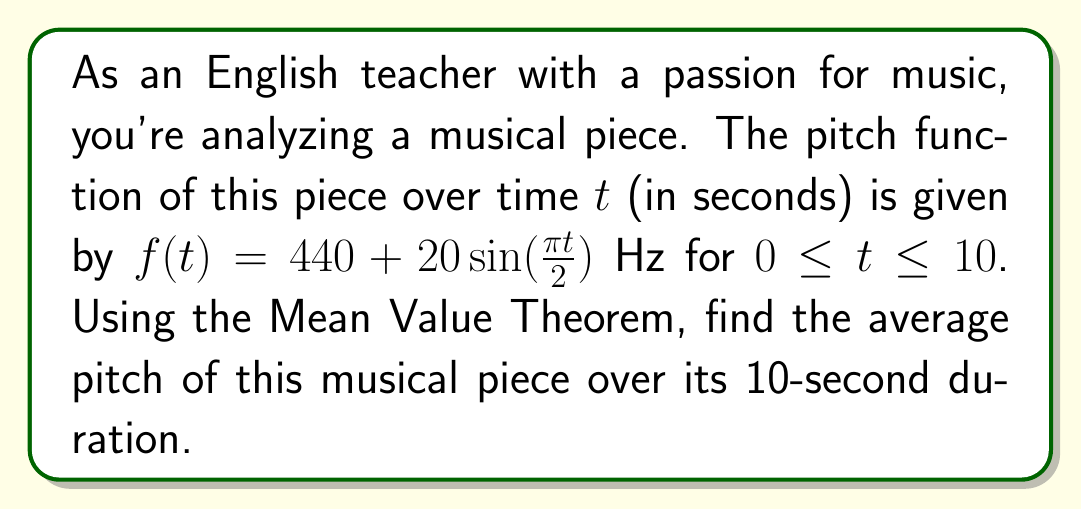Can you solve this math problem? To solve this problem, we'll use the Mean Value Theorem for integrals, which states that for a continuous function $f(t)$ on an interval $[a,b]$, there exists a point $c$ in $(a,b)$ such that:

$$\frac{1}{b-a}\int_a^b f(t)dt = f(c)$$

Where the left side of the equation represents the average value of the function over the interval.

Step 1: Set up the integral for the average pitch.
$$\text{Average Pitch} = \frac{1}{10-0}\int_0^{10} (440 + 20\sin(\frac{\pi t}{2})) dt$$

Step 2: Simplify the integral.
$$\text{Average Pitch} = \frac{1}{10}\int_0^{10} (440 + 20\sin(\frac{\pi t}{2})) dt$$

Step 3: Integrate the function.
$$\int (440 + 20\sin(\frac{\pi t}{2})) dt = 440t - \frac{40}{\pi}\cos(\frac{\pi t}{2}) + C$$

Step 4: Apply the limits of integration.
$$\text{Average Pitch} = \frac{1}{10}\left[(440t - \frac{40}{\pi}\cos(\frac{\pi t}{2}))\right]_0^{10}$$

Step 5: Evaluate the integral.
$$\text{Average Pitch} = \frac{1}{10}\left[(4400 - \frac{40}{\pi}\cos(5\pi)) - (0 - \frac{40}{\pi}\cos(0))\right]$$

Step 6: Simplify.
$$\text{Average Pitch} = \frac{1}{10}\left[4400 - \frac{40}{\pi}(-1) + \frac{40}{\pi}\right] = \frac{1}{10}\left[4400 + \frac{80}{\pi}\right]$$

Step 7: Calculate the final result.
$$\text{Average Pitch} = 440 + \frac{8}{\pi} \approx 442.55 \text{ Hz}$$
Answer: $440 + \frac{8}{\pi}$ Hz 